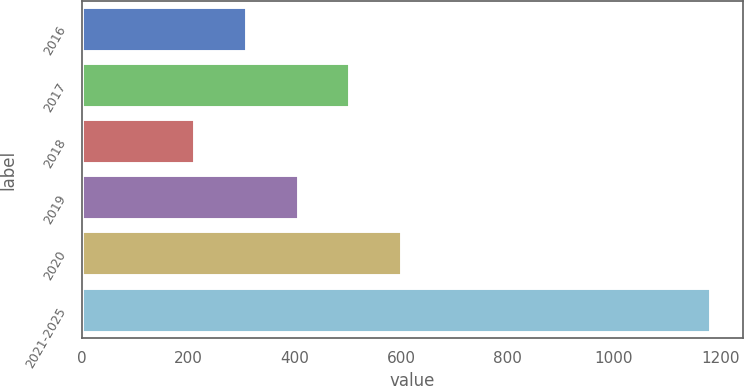Convert chart. <chart><loc_0><loc_0><loc_500><loc_500><bar_chart><fcel>2016<fcel>2017<fcel>2018<fcel>2019<fcel>2020<fcel>2021-2025<nl><fcel>310.9<fcel>504.7<fcel>214<fcel>407.8<fcel>601.6<fcel>1183<nl></chart> 